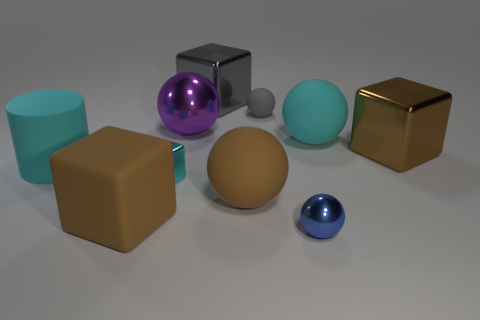Subtract all blue spheres. How many spheres are left? 4 Subtract all purple metal spheres. How many spheres are left? 4 Subtract all red balls. Subtract all green cubes. How many balls are left? 5 Subtract all cylinders. How many objects are left? 9 Add 6 cyan rubber balls. How many cyan rubber balls exist? 7 Subtract 1 cyan cylinders. How many objects are left? 9 Subtract all small cyan metallic objects. Subtract all big metal blocks. How many objects are left? 7 Add 5 large purple metal balls. How many large purple metal balls are left? 6 